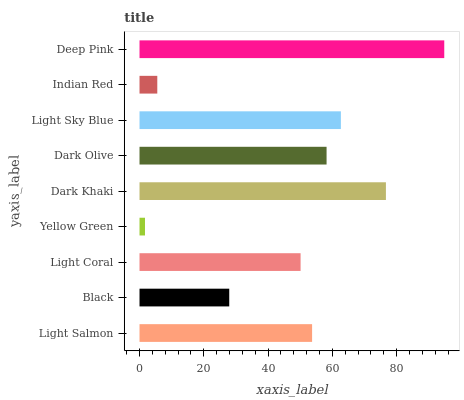Is Yellow Green the minimum?
Answer yes or no. Yes. Is Deep Pink the maximum?
Answer yes or no. Yes. Is Black the minimum?
Answer yes or no. No. Is Black the maximum?
Answer yes or no. No. Is Light Salmon greater than Black?
Answer yes or no. Yes. Is Black less than Light Salmon?
Answer yes or no. Yes. Is Black greater than Light Salmon?
Answer yes or no. No. Is Light Salmon less than Black?
Answer yes or no. No. Is Light Salmon the high median?
Answer yes or no. Yes. Is Light Salmon the low median?
Answer yes or no. Yes. Is Yellow Green the high median?
Answer yes or no. No. Is Light Coral the low median?
Answer yes or no. No. 